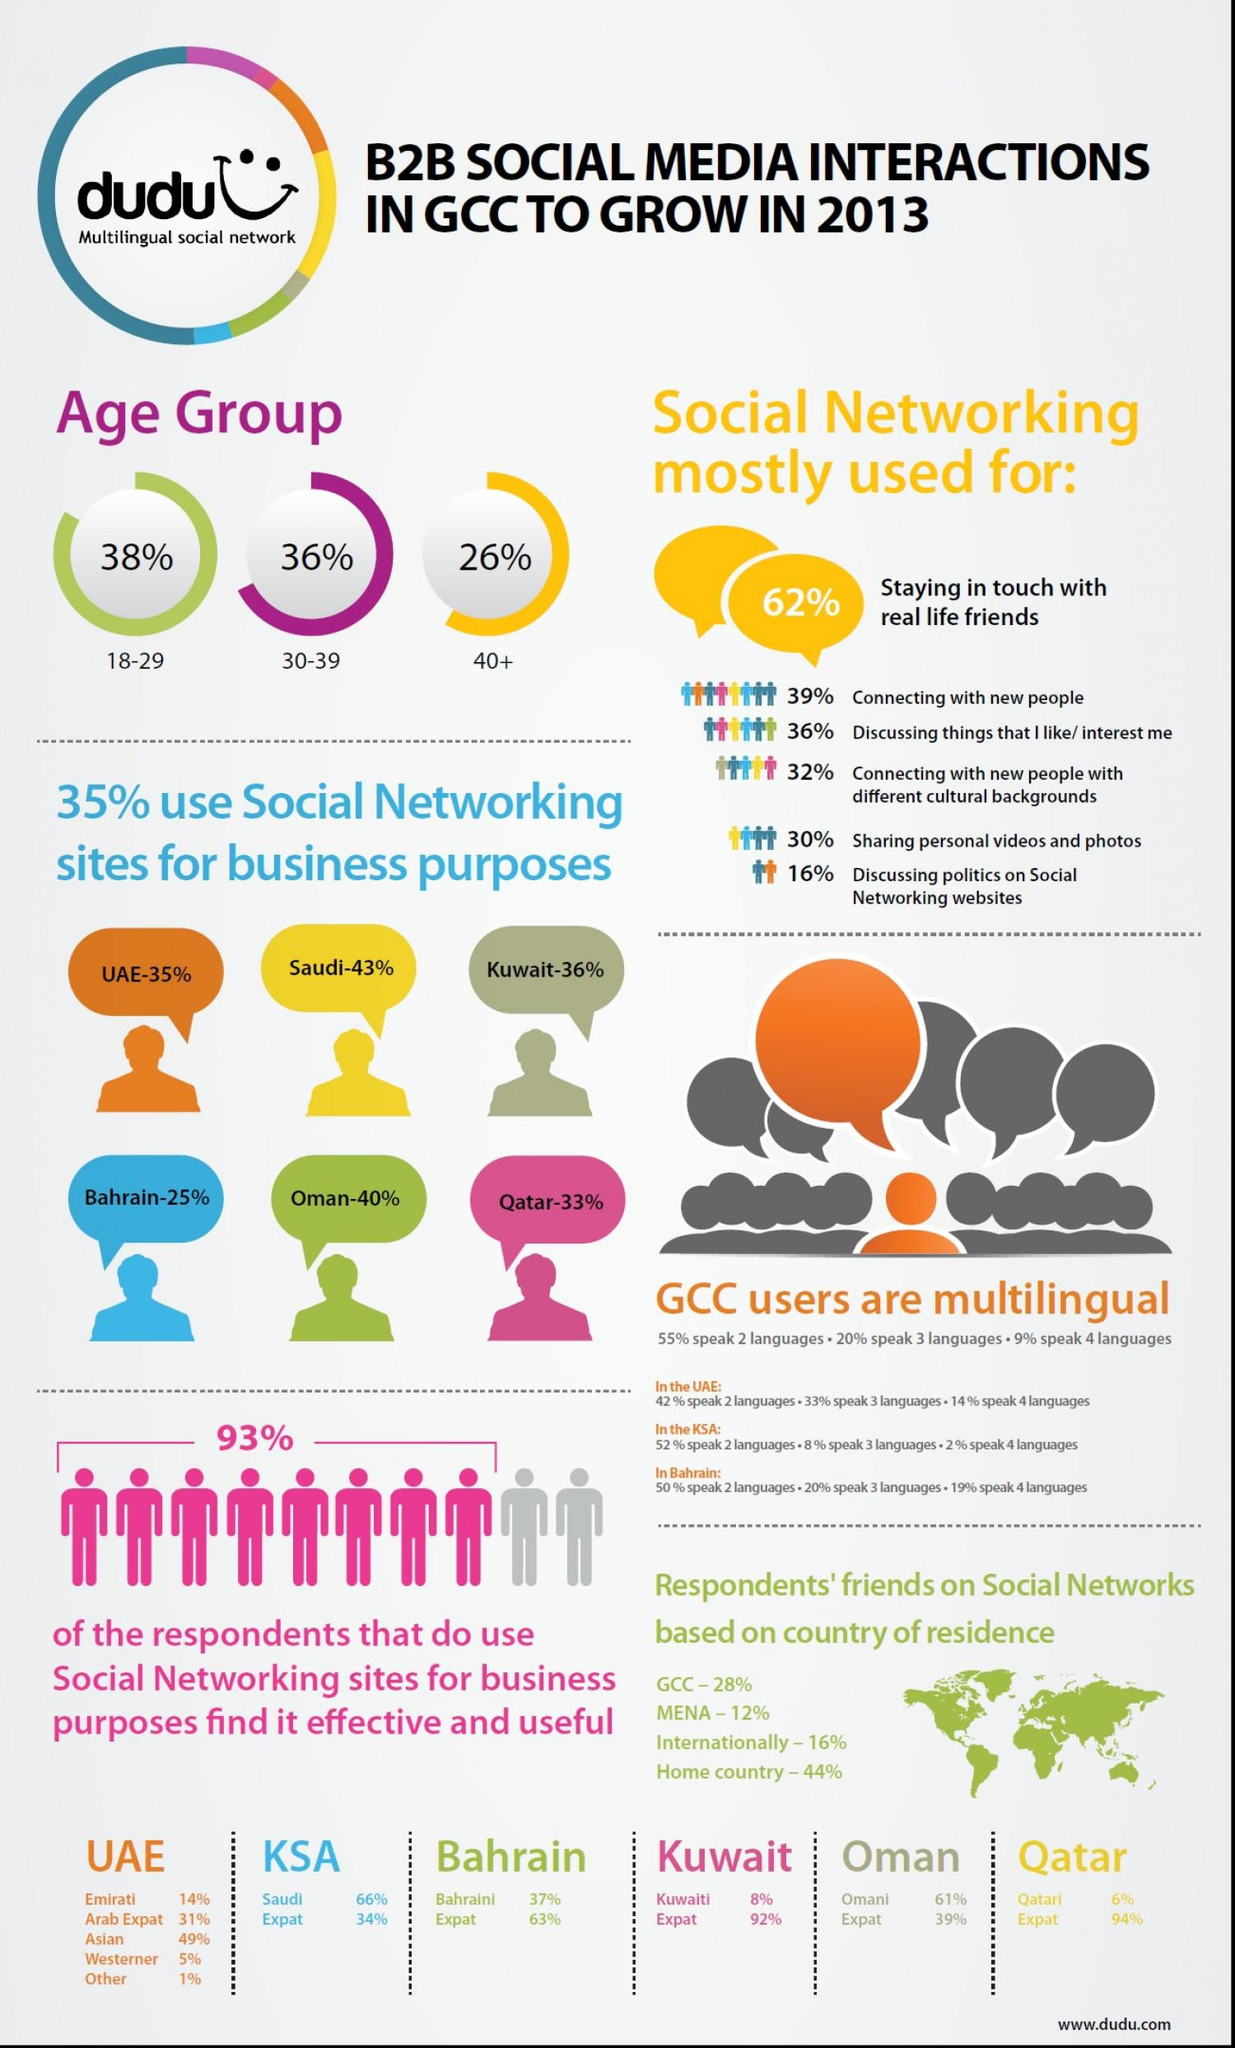Specify some key components in this picture. The use of social networking among individuals in the age group 18-29 is 2% higher than among individuals aged 30-39. Approximately 10% of individuals in the age group 30-39 use social networking, compared to only 40% of those aged 40 and older. The infographic features countries from both Asia and Africa, representing the diversity of continents represented in the graphic. According to a survey, 74% of people in the age group of 18-39 use social networking. 